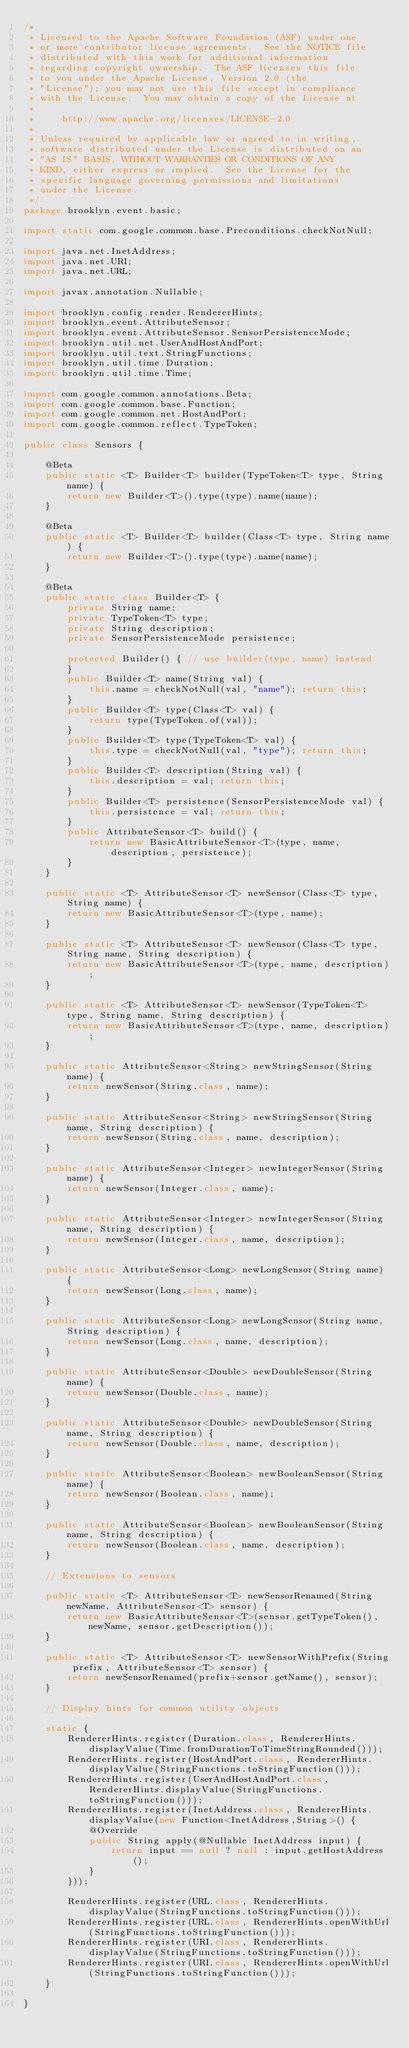<code> <loc_0><loc_0><loc_500><loc_500><_Java_>/*
 * Licensed to the Apache Software Foundation (ASF) under one
 * or more contributor license agreements.  See the NOTICE file
 * distributed with this work for additional information
 * regarding copyright ownership.  The ASF licenses this file
 * to you under the Apache License, Version 2.0 (the
 * "License"); you may not use this file except in compliance
 * with the License.  You may obtain a copy of the License at
 *
 *     http://www.apache.org/licenses/LICENSE-2.0
 *
 * Unless required by applicable law or agreed to in writing,
 * software distributed under the License is distributed on an
 * "AS IS" BASIS, WITHOUT WARRANTIES OR CONDITIONS OF ANY
 * KIND, either express or implied.  See the License for the
 * specific language governing permissions and limitations
 * under the License.
 */
package brooklyn.event.basic;

import static com.google.common.base.Preconditions.checkNotNull;

import java.net.InetAddress;
import java.net.URI;
import java.net.URL;

import javax.annotation.Nullable;

import brooklyn.config.render.RendererHints;
import brooklyn.event.AttributeSensor;
import brooklyn.event.AttributeSensor.SensorPersistenceMode;
import brooklyn.util.net.UserAndHostAndPort;
import brooklyn.util.text.StringFunctions;
import brooklyn.util.time.Duration;
import brooklyn.util.time.Time;

import com.google.common.annotations.Beta;
import com.google.common.base.Function;
import com.google.common.net.HostAndPort;
import com.google.common.reflect.TypeToken;

public class Sensors {

    @Beta
    public static <T> Builder<T> builder(TypeToken<T> type, String name) {
        return new Builder<T>().type(type).name(name);
    }

    @Beta
    public static <T> Builder<T> builder(Class<T> type, String name) {
        return new Builder<T>().type(type).name(name);
    }
    
    @Beta
    public static class Builder<T> {
        private String name;
        private TypeToken<T> type;
        private String description;
        private SensorPersistenceMode persistence;
        
        protected Builder() { // use builder(type, name) instead
        }
        public Builder<T> name(String val) {
            this.name = checkNotNull(val, "name"); return this;
        }
        public Builder<T> type(Class<T> val) {
            return type(TypeToken.of(val));
        }
        public Builder<T> type(TypeToken<T> val) {
            this.type = checkNotNull(val, "type"); return this;
        }
        public Builder<T> description(String val) {
            this.description = val; return this;
        }
        public Builder<T> persistence(SensorPersistenceMode val) {
            this.persistence = val; return this;
        }
        public AttributeSensor<T> build() {
            return new BasicAttributeSensor<T>(type, name, description, persistence);
        }
    }

    public static <T> AttributeSensor<T> newSensor(Class<T> type, String name) {
        return new BasicAttributeSensor<T>(type, name);
    }

    public static <T> AttributeSensor<T> newSensor(Class<T> type, String name, String description) {
        return new BasicAttributeSensor<T>(type, name, description);
    }

    public static <T> AttributeSensor<T> newSensor(TypeToken<T> type, String name, String description) {
        return new BasicAttributeSensor<T>(type, name, description);
    }

    public static AttributeSensor<String> newStringSensor(String name) {
        return newSensor(String.class, name);
    }

    public static AttributeSensor<String> newStringSensor(String name, String description) {
        return newSensor(String.class, name, description);
    }

    public static AttributeSensor<Integer> newIntegerSensor(String name) {
        return newSensor(Integer.class, name);
    }

    public static AttributeSensor<Integer> newIntegerSensor(String name, String description) {
        return newSensor(Integer.class, name, description);
    }

    public static AttributeSensor<Long> newLongSensor(String name) {
        return newSensor(Long.class, name);
    }

    public static AttributeSensor<Long> newLongSensor(String name, String description) {
        return newSensor(Long.class, name, description);
    }

    public static AttributeSensor<Double> newDoubleSensor(String name) {
        return newSensor(Double.class, name);
    }

    public static AttributeSensor<Double> newDoubleSensor(String name, String description) {
        return newSensor(Double.class, name, description);
    }

    public static AttributeSensor<Boolean> newBooleanSensor(String name) {
        return newSensor(Boolean.class, name);
    }

    public static AttributeSensor<Boolean> newBooleanSensor(String name, String description) {
        return newSensor(Boolean.class, name, description);
    }

    // Extensions to sensors

    public static <T> AttributeSensor<T> newSensorRenamed(String newName, AttributeSensor<T> sensor) {
        return new BasicAttributeSensor<T>(sensor.getTypeToken(), newName, sensor.getDescription());
    }

    public static <T> AttributeSensor<T> newSensorWithPrefix(String prefix, AttributeSensor<T> sensor) {
        return newSensorRenamed(prefix+sensor.getName(), sensor);
    }

    // Display hints for common utility objects

    static {
        RendererHints.register(Duration.class, RendererHints.displayValue(Time.fromDurationToTimeStringRounded()));
        RendererHints.register(HostAndPort.class, RendererHints.displayValue(StringFunctions.toStringFunction()));
        RendererHints.register(UserAndHostAndPort.class, RendererHints.displayValue(StringFunctions.toStringFunction()));
        RendererHints.register(InetAddress.class, RendererHints.displayValue(new Function<InetAddress,String>() {
            @Override
            public String apply(@Nullable InetAddress input) {
                return input == null ? null : input.getHostAddress();
            }
        }));

        RendererHints.register(URL.class, RendererHints.displayValue(StringFunctions.toStringFunction()));
        RendererHints.register(URL.class, RendererHints.openWithUrl(StringFunctions.toStringFunction()));
        RendererHints.register(URI.class, RendererHints.displayValue(StringFunctions.toStringFunction()));
        RendererHints.register(URI.class, RendererHints.openWithUrl(StringFunctions.toStringFunction()));
    }

}
</code> 